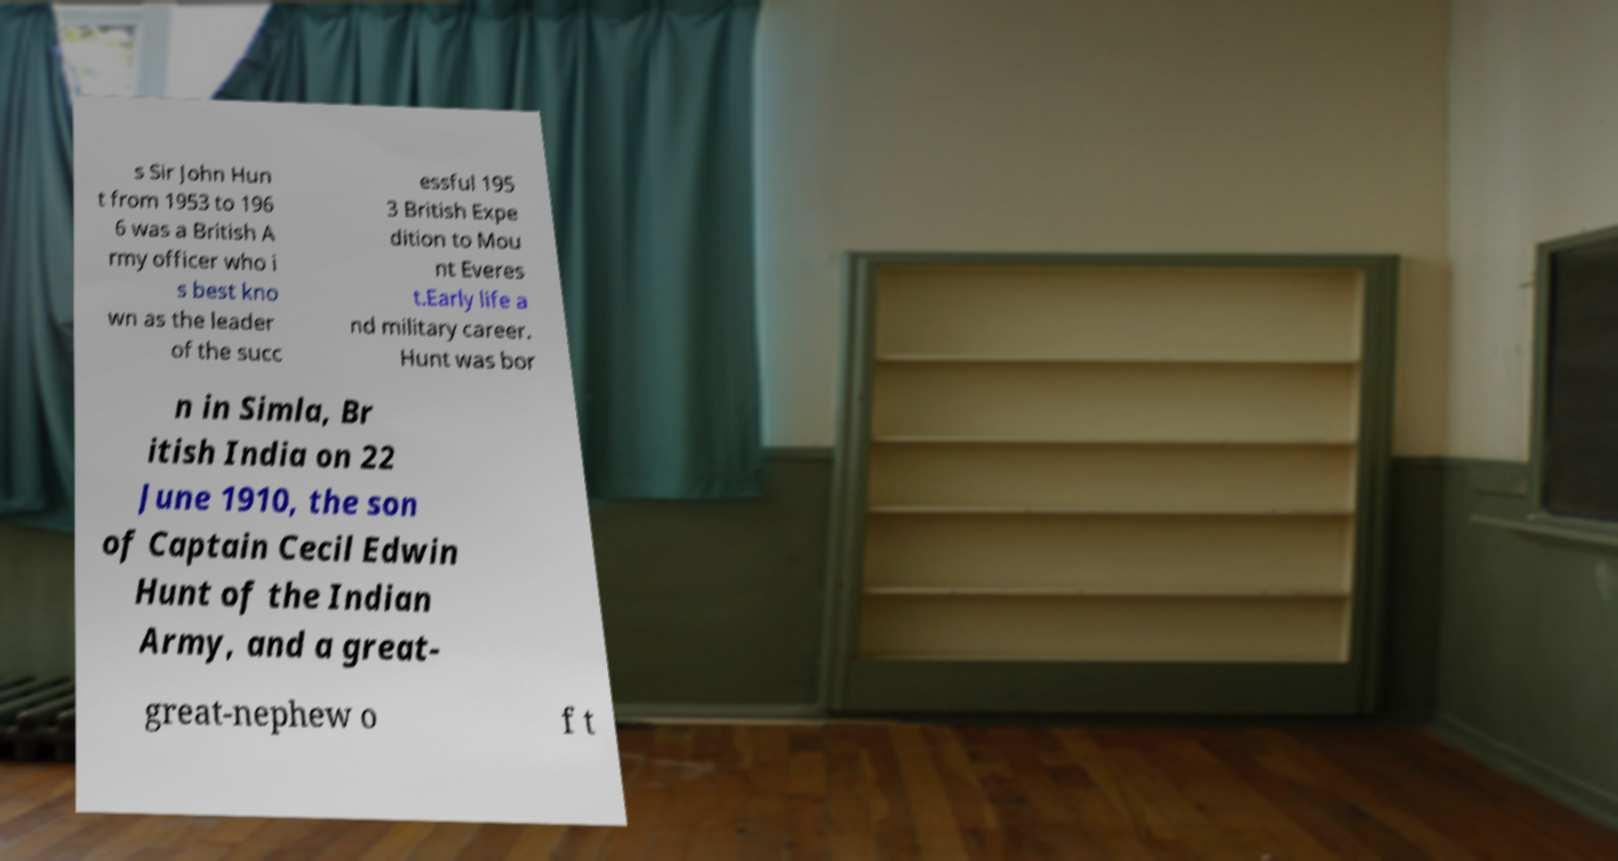Could you extract and type out the text from this image? s Sir John Hun t from 1953 to 196 6 was a British A rmy officer who i s best kno wn as the leader of the succ essful 195 3 British Expe dition to Mou nt Everes t.Early life a nd military career. Hunt was bor n in Simla, Br itish India on 22 June 1910, the son of Captain Cecil Edwin Hunt of the Indian Army, and a great- great-nephew o f t 